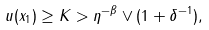<formula> <loc_0><loc_0><loc_500><loc_500>u ( x _ { 1 } ) \geq K > \eta ^ { - \beta } \vee ( 1 + \delta ^ { - 1 } ) ,</formula> 